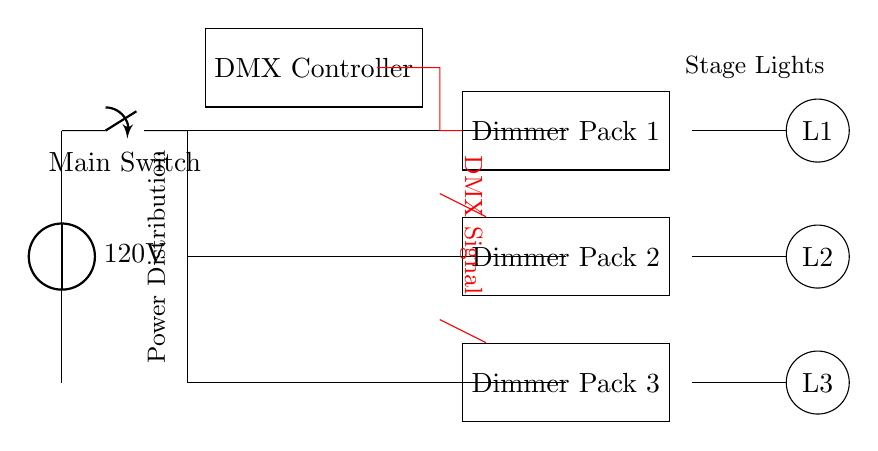What is the voltage of the circuit? The circuit diagram indicates that the voltage source is labeled as 120 volts. This is the potential difference provided to power the lighting system.
Answer: 120 volts How many dimmer packs are present in the circuit? The circuit diagram shows three dimmer packs labeled as Dimmer Pack 1, Dimmer Pack 2, and Dimmer Pack 3. By counting these components, we find the total.
Answer: Three What component connects the power source to the dimmer packs? The main switch in the diagram controls the flow of power from the voltage source to the dimmer packs. It is located immediately after the voltage source.
Answer: Main switch What is the role of the DMX controller in this circuit? The DMX controller communicates with the dimmer packs to regulate the brightness and effects of the stage lights using a digital signal. It acts as the control hub for dynamic theatrical lighting.
Answer: Control hub How are the lights connected to the dimmer packs? The lights L1, L2, and L3 are connected to the corresponding dimmer packs where each light is energized based on the output from each dimmer pack. Specifically, the diagram shows lines indicating connections from each dimmer pack to each light.
Answer: Through connections from dimmer packs What type of signal is indicated by the red lines in the circuit diagram? The red lines represent the DMX signal that is transmitted from the DMX controller to the dimmer packs. This signal is essential for controlling the intensity of the lights dynamically during performances.
Answer: DMX signal Which component is responsible for controlling the overall power flow in this circuit? The main switch is the component that controls the overall power flow, allowing the circuit to be turned on or off. It is situated right after the voltage source, indicating its primary role in power management.
Answer: Main switch 